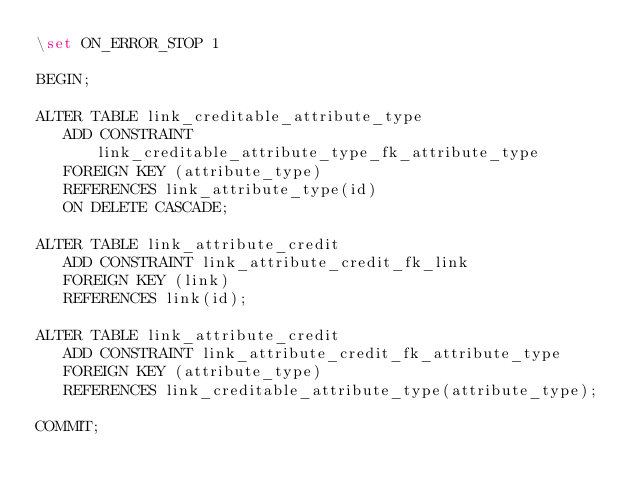Convert code to text. <code><loc_0><loc_0><loc_500><loc_500><_SQL_>\set ON_ERROR_STOP 1

BEGIN;

ALTER TABLE link_creditable_attribute_type
   ADD CONSTRAINT link_creditable_attribute_type_fk_attribute_type
   FOREIGN KEY (attribute_type)
   REFERENCES link_attribute_type(id)
   ON DELETE CASCADE;

ALTER TABLE link_attribute_credit
   ADD CONSTRAINT link_attribute_credit_fk_link
   FOREIGN KEY (link)
   REFERENCES link(id);

ALTER TABLE link_attribute_credit
   ADD CONSTRAINT link_attribute_credit_fk_attribute_type
   FOREIGN KEY (attribute_type)
   REFERENCES link_creditable_attribute_type(attribute_type);

COMMIT;
</code> 